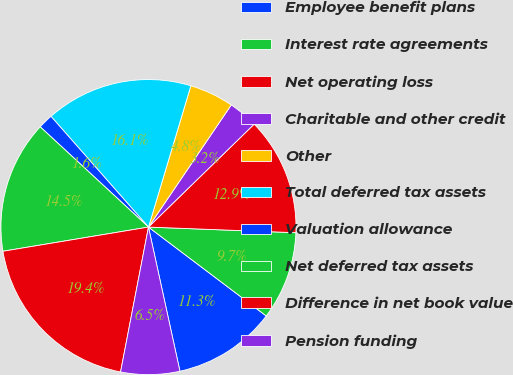Convert chart. <chart><loc_0><loc_0><loc_500><loc_500><pie_chart><fcel>Employee benefit plans<fcel>Interest rate agreements<fcel>Net operating loss<fcel>Charitable and other credit<fcel>Other<fcel>Total deferred tax assets<fcel>Valuation allowance<fcel>Net deferred tax assets<fcel>Difference in net book value<fcel>Pension funding<nl><fcel>11.29%<fcel>9.68%<fcel>12.9%<fcel>3.23%<fcel>4.84%<fcel>16.13%<fcel>1.62%<fcel>14.51%<fcel>19.35%<fcel>6.45%<nl></chart> 